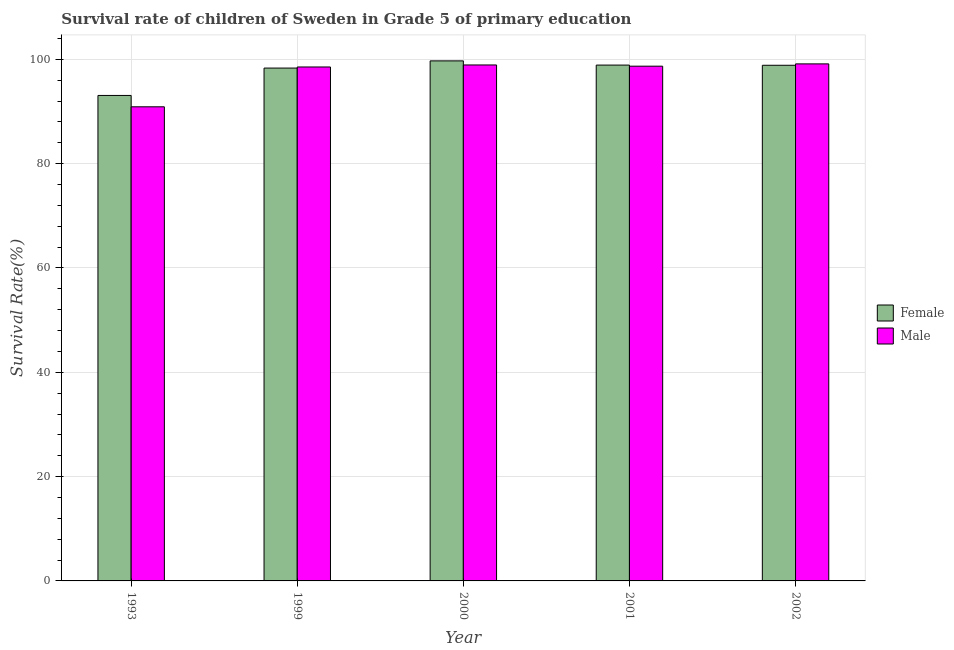How many different coloured bars are there?
Your answer should be compact. 2. How many groups of bars are there?
Offer a very short reply. 5. Are the number of bars per tick equal to the number of legend labels?
Ensure brevity in your answer.  Yes. How many bars are there on the 2nd tick from the left?
Ensure brevity in your answer.  2. What is the label of the 1st group of bars from the left?
Keep it short and to the point. 1993. In how many cases, is the number of bars for a given year not equal to the number of legend labels?
Ensure brevity in your answer.  0. What is the survival rate of male students in primary education in 2001?
Offer a terse response. 98.69. Across all years, what is the maximum survival rate of female students in primary education?
Keep it short and to the point. 99.7. Across all years, what is the minimum survival rate of female students in primary education?
Give a very brief answer. 93.08. In which year was the survival rate of female students in primary education minimum?
Provide a short and direct response. 1993. What is the total survival rate of female students in primary education in the graph?
Provide a succinct answer. 488.87. What is the difference between the survival rate of female students in primary education in 1999 and that in 2001?
Your answer should be compact. -0.57. What is the difference between the survival rate of female students in primary education in 2001 and the survival rate of male students in primary education in 1993?
Your answer should be compact. 5.82. What is the average survival rate of male students in primary education per year?
Give a very brief answer. 97.23. What is the ratio of the survival rate of male students in primary education in 1999 to that in 2002?
Offer a terse response. 0.99. Is the difference between the survival rate of female students in primary education in 1999 and 2002 greater than the difference between the survival rate of male students in primary education in 1999 and 2002?
Ensure brevity in your answer.  No. What is the difference between the highest and the second highest survival rate of male students in primary education?
Provide a succinct answer. 0.21. What is the difference between the highest and the lowest survival rate of male students in primary education?
Provide a succinct answer. 8.23. In how many years, is the survival rate of female students in primary education greater than the average survival rate of female students in primary education taken over all years?
Offer a very short reply. 4. Is the sum of the survival rate of male students in primary education in 2000 and 2001 greater than the maximum survival rate of female students in primary education across all years?
Your response must be concise. Yes. How many bars are there?
Offer a very short reply. 10. Are all the bars in the graph horizontal?
Offer a terse response. No. Does the graph contain any zero values?
Offer a very short reply. No. How many legend labels are there?
Ensure brevity in your answer.  2. How are the legend labels stacked?
Your response must be concise. Vertical. What is the title of the graph?
Your response must be concise. Survival rate of children of Sweden in Grade 5 of primary education. Does "Commercial service exports" appear as one of the legend labels in the graph?
Your answer should be compact. No. What is the label or title of the Y-axis?
Your answer should be compact. Survival Rate(%). What is the Survival Rate(%) of Female in 1993?
Keep it short and to the point. 93.08. What is the Survival Rate(%) in Male in 1993?
Offer a very short reply. 90.9. What is the Survival Rate(%) of Female in 1999?
Your response must be concise. 98.33. What is the Survival Rate(%) in Male in 1999?
Give a very brief answer. 98.54. What is the Survival Rate(%) of Female in 2000?
Your answer should be compact. 99.7. What is the Survival Rate(%) of Male in 2000?
Your response must be concise. 98.92. What is the Survival Rate(%) in Female in 2001?
Your response must be concise. 98.9. What is the Survival Rate(%) in Male in 2001?
Give a very brief answer. 98.69. What is the Survival Rate(%) in Female in 2002?
Ensure brevity in your answer.  98.86. What is the Survival Rate(%) of Male in 2002?
Your answer should be very brief. 99.13. Across all years, what is the maximum Survival Rate(%) of Female?
Your answer should be compact. 99.7. Across all years, what is the maximum Survival Rate(%) of Male?
Give a very brief answer. 99.13. Across all years, what is the minimum Survival Rate(%) in Female?
Ensure brevity in your answer.  93.08. Across all years, what is the minimum Survival Rate(%) in Male?
Your answer should be very brief. 90.9. What is the total Survival Rate(%) of Female in the graph?
Your response must be concise. 488.87. What is the total Survival Rate(%) in Male in the graph?
Offer a very short reply. 486.17. What is the difference between the Survival Rate(%) of Female in 1993 and that in 1999?
Offer a terse response. -5.25. What is the difference between the Survival Rate(%) of Male in 1993 and that in 1999?
Your answer should be compact. -7.64. What is the difference between the Survival Rate(%) in Female in 1993 and that in 2000?
Your answer should be compact. -6.63. What is the difference between the Survival Rate(%) of Male in 1993 and that in 2000?
Offer a terse response. -8.02. What is the difference between the Survival Rate(%) of Female in 1993 and that in 2001?
Make the answer very short. -5.82. What is the difference between the Survival Rate(%) of Male in 1993 and that in 2001?
Offer a terse response. -7.79. What is the difference between the Survival Rate(%) in Female in 1993 and that in 2002?
Provide a succinct answer. -5.78. What is the difference between the Survival Rate(%) in Male in 1993 and that in 2002?
Your response must be concise. -8.23. What is the difference between the Survival Rate(%) in Female in 1999 and that in 2000?
Ensure brevity in your answer.  -1.38. What is the difference between the Survival Rate(%) in Male in 1999 and that in 2000?
Give a very brief answer. -0.39. What is the difference between the Survival Rate(%) in Female in 1999 and that in 2001?
Ensure brevity in your answer.  -0.57. What is the difference between the Survival Rate(%) of Male in 1999 and that in 2001?
Provide a succinct answer. -0.15. What is the difference between the Survival Rate(%) of Female in 1999 and that in 2002?
Your response must be concise. -0.54. What is the difference between the Survival Rate(%) of Male in 1999 and that in 2002?
Ensure brevity in your answer.  -0.59. What is the difference between the Survival Rate(%) of Female in 2000 and that in 2001?
Keep it short and to the point. 0.81. What is the difference between the Survival Rate(%) in Male in 2000 and that in 2001?
Offer a terse response. 0.23. What is the difference between the Survival Rate(%) in Female in 2000 and that in 2002?
Make the answer very short. 0.84. What is the difference between the Survival Rate(%) in Male in 2000 and that in 2002?
Keep it short and to the point. -0.21. What is the difference between the Survival Rate(%) in Female in 2001 and that in 2002?
Make the answer very short. 0.04. What is the difference between the Survival Rate(%) of Male in 2001 and that in 2002?
Ensure brevity in your answer.  -0.44. What is the difference between the Survival Rate(%) in Female in 1993 and the Survival Rate(%) in Male in 1999?
Offer a terse response. -5.46. What is the difference between the Survival Rate(%) in Female in 1993 and the Survival Rate(%) in Male in 2000?
Your response must be concise. -5.84. What is the difference between the Survival Rate(%) of Female in 1993 and the Survival Rate(%) of Male in 2001?
Provide a short and direct response. -5.61. What is the difference between the Survival Rate(%) of Female in 1993 and the Survival Rate(%) of Male in 2002?
Make the answer very short. -6.05. What is the difference between the Survival Rate(%) in Female in 1999 and the Survival Rate(%) in Male in 2000?
Give a very brief answer. -0.6. What is the difference between the Survival Rate(%) of Female in 1999 and the Survival Rate(%) of Male in 2001?
Make the answer very short. -0.36. What is the difference between the Survival Rate(%) in Female in 1999 and the Survival Rate(%) in Male in 2002?
Offer a terse response. -0.8. What is the difference between the Survival Rate(%) of Female in 2000 and the Survival Rate(%) of Male in 2001?
Make the answer very short. 1.02. What is the difference between the Survival Rate(%) of Female in 2000 and the Survival Rate(%) of Male in 2002?
Provide a succinct answer. 0.58. What is the difference between the Survival Rate(%) in Female in 2001 and the Survival Rate(%) in Male in 2002?
Your answer should be compact. -0.23. What is the average Survival Rate(%) in Female per year?
Your answer should be compact. 97.77. What is the average Survival Rate(%) of Male per year?
Ensure brevity in your answer.  97.23. In the year 1993, what is the difference between the Survival Rate(%) of Female and Survival Rate(%) of Male?
Keep it short and to the point. 2.18. In the year 1999, what is the difference between the Survival Rate(%) of Female and Survival Rate(%) of Male?
Your answer should be compact. -0.21. In the year 2000, what is the difference between the Survival Rate(%) in Female and Survival Rate(%) in Male?
Keep it short and to the point. 0.78. In the year 2001, what is the difference between the Survival Rate(%) in Female and Survival Rate(%) in Male?
Keep it short and to the point. 0.21. In the year 2002, what is the difference between the Survival Rate(%) of Female and Survival Rate(%) of Male?
Offer a terse response. -0.27. What is the ratio of the Survival Rate(%) of Female in 1993 to that in 1999?
Offer a very short reply. 0.95. What is the ratio of the Survival Rate(%) in Male in 1993 to that in 1999?
Offer a very short reply. 0.92. What is the ratio of the Survival Rate(%) in Female in 1993 to that in 2000?
Provide a succinct answer. 0.93. What is the ratio of the Survival Rate(%) of Male in 1993 to that in 2000?
Give a very brief answer. 0.92. What is the ratio of the Survival Rate(%) of Male in 1993 to that in 2001?
Keep it short and to the point. 0.92. What is the ratio of the Survival Rate(%) of Female in 1993 to that in 2002?
Offer a terse response. 0.94. What is the ratio of the Survival Rate(%) of Male in 1993 to that in 2002?
Offer a terse response. 0.92. What is the ratio of the Survival Rate(%) of Female in 1999 to that in 2000?
Offer a very short reply. 0.99. What is the ratio of the Survival Rate(%) of Male in 1999 to that in 2001?
Keep it short and to the point. 1. What is the ratio of the Survival Rate(%) in Female in 1999 to that in 2002?
Provide a succinct answer. 0.99. What is the ratio of the Survival Rate(%) of Female in 2000 to that in 2001?
Give a very brief answer. 1.01. What is the ratio of the Survival Rate(%) of Male in 2000 to that in 2001?
Give a very brief answer. 1. What is the ratio of the Survival Rate(%) of Female in 2000 to that in 2002?
Offer a very short reply. 1.01. What is the ratio of the Survival Rate(%) in Male in 2000 to that in 2002?
Offer a terse response. 1. What is the difference between the highest and the second highest Survival Rate(%) in Female?
Your response must be concise. 0.81. What is the difference between the highest and the second highest Survival Rate(%) in Male?
Your answer should be compact. 0.21. What is the difference between the highest and the lowest Survival Rate(%) of Female?
Offer a terse response. 6.63. What is the difference between the highest and the lowest Survival Rate(%) in Male?
Keep it short and to the point. 8.23. 